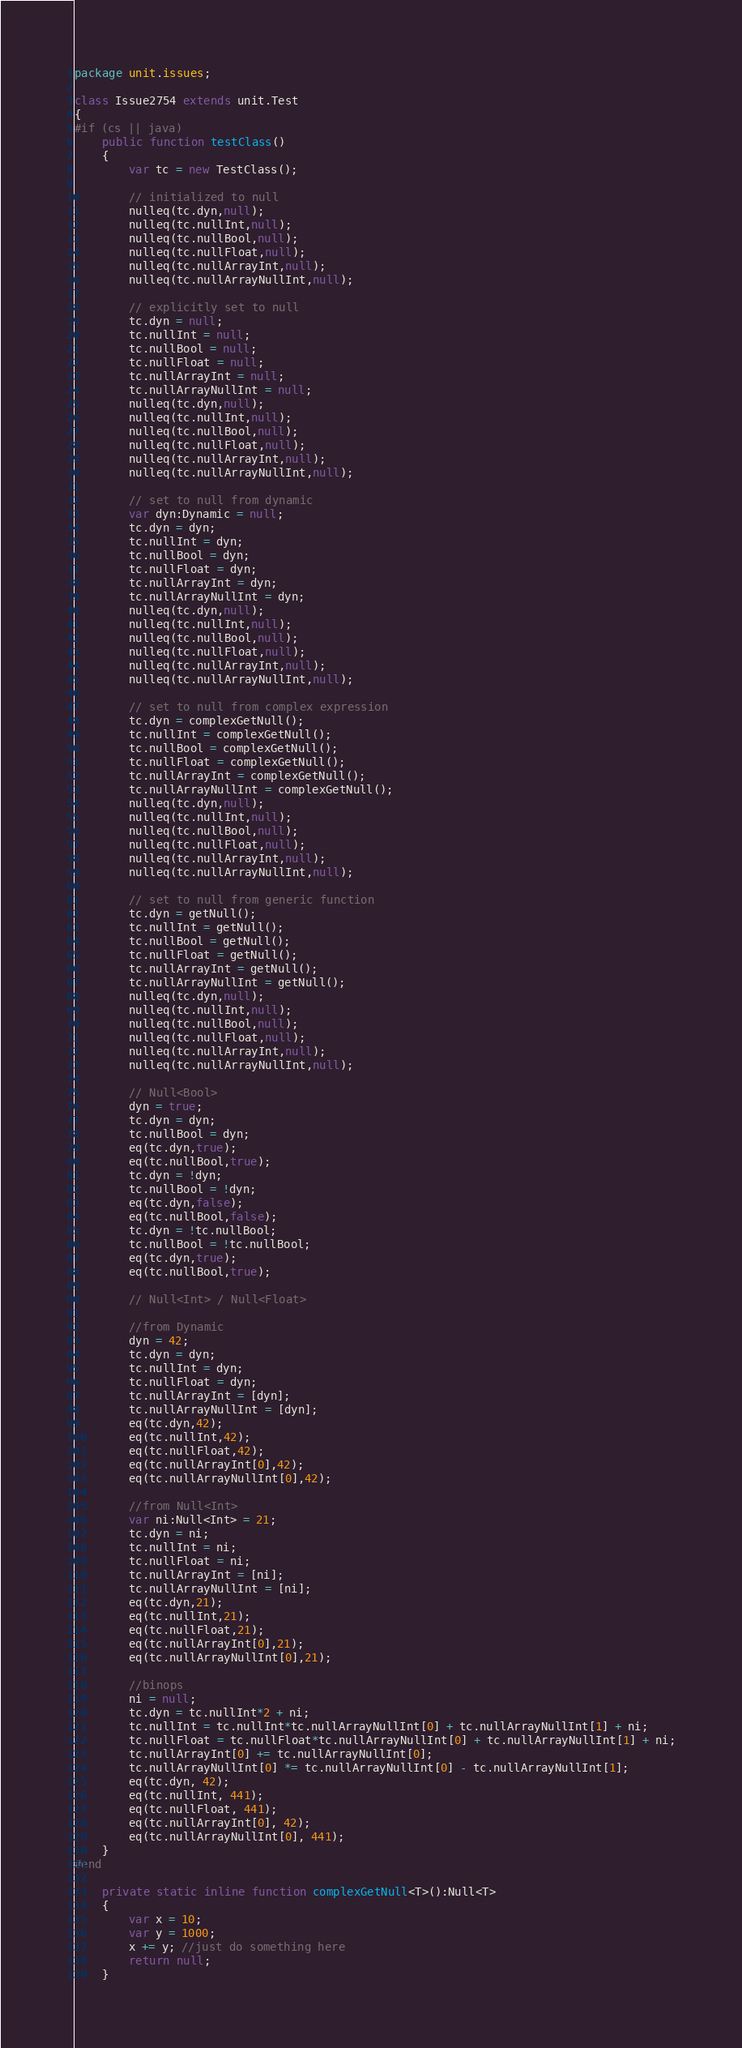<code> <loc_0><loc_0><loc_500><loc_500><_Haxe_>package unit.issues;

class Issue2754 extends unit.Test
{
#if (cs || java)
	public function testClass()
	{
		var tc = new TestClass();

		// initialized to null
		nulleq(tc.dyn,null);
		nulleq(tc.nullInt,null);
		nulleq(tc.nullBool,null);
		nulleq(tc.nullFloat,null);
		nulleq(tc.nullArrayInt,null);
		nulleq(tc.nullArrayNullInt,null);

		// explicitly set to null
		tc.dyn = null;
		tc.nullInt = null;
		tc.nullBool = null;
		tc.nullFloat = null;
		tc.nullArrayInt = null;
		tc.nullArrayNullInt = null;
		nulleq(tc.dyn,null);
		nulleq(tc.nullInt,null);
		nulleq(tc.nullBool,null);
		nulleq(tc.nullFloat,null);
		nulleq(tc.nullArrayInt,null);
		nulleq(tc.nullArrayNullInt,null);

		// set to null from dynamic
		var dyn:Dynamic = null;
		tc.dyn = dyn;
		tc.nullInt = dyn;
		tc.nullBool = dyn;
		tc.nullFloat = dyn;
		tc.nullArrayInt = dyn;
		tc.nullArrayNullInt = dyn;
		nulleq(tc.dyn,null);
		nulleq(tc.nullInt,null);
		nulleq(tc.nullBool,null);
		nulleq(tc.nullFloat,null);
		nulleq(tc.nullArrayInt,null);
		nulleq(tc.nullArrayNullInt,null);

		// set to null from complex expression
		tc.dyn = complexGetNull();
		tc.nullInt = complexGetNull();
		tc.nullBool = complexGetNull();
		tc.nullFloat = complexGetNull();
		tc.nullArrayInt = complexGetNull();
		tc.nullArrayNullInt = complexGetNull();
		nulleq(tc.dyn,null);
		nulleq(tc.nullInt,null);
		nulleq(tc.nullBool,null);
		nulleq(tc.nullFloat,null);
		nulleq(tc.nullArrayInt,null);
		nulleq(tc.nullArrayNullInt,null);

		// set to null from generic function
		tc.dyn = getNull();
		tc.nullInt = getNull();
		tc.nullBool = getNull();
		tc.nullFloat = getNull();
		tc.nullArrayInt = getNull();
		tc.nullArrayNullInt = getNull();
		nulleq(tc.dyn,null);
		nulleq(tc.nullInt,null);
		nulleq(tc.nullBool,null);
		nulleq(tc.nullFloat,null);
		nulleq(tc.nullArrayInt,null);
		nulleq(tc.nullArrayNullInt,null);

		// Null<Bool>
		dyn = true;
		tc.dyn = dyn;
		tc.nullBool = dyn;
		eq(tc.dyn,true);
		eq(tc.nullBool,true);
		tc.dyn = !dyn;
		tc.nullBool = !dyn;
		eq(tc.dyn,false);
		eq(tc.nullBool,false);
		tc.dyn = !tc.nullBool;
		tc.nullBool = !tc.nullBool;
		eq(tc.dyn,true);
		eq(tc.nullBool,true);

		// Null<Int> / Null<Float>

		//from Dynamic
		dyn = 42;
		tc.dyn = dyn;
		tc.nullInt = dyn;
		tc.nullFloat = dyn;
		tc.nullArrayInt = [dyn];
		tc.nullArrayNullInt = [dyn];
		eq(tc.dyn,42);
		eq(tc.nullInt,42);
		eq(tc.nullFloat,42);
		eq(tc.nullArrayInt[0],42);
		eq(tc.nullArrayNullInt[0],42);

		//from Null<Int>
		var ni:Null<Int> = 21;
		tc.dyn = ni;
		tc.nullInt = ni;
		tc.nullFloat = ni;
		tc.nullArrayInt = [ni];
		tc.nullArrayNullInt = [ni];
		eq(tc.dyn,21);
		eq(tc.nullInt,21);
		eq(tc.nullFloat,21);
		eq(tc.nullArrayInt[0],21);
		eq(tc.nullArrayNullInt[0],21);

		//binops
		ni = null;
		tc.dyn = tc.nullInt*2 + ni;
		tc.nullInt = tc.nullInt*tc.nullArrayNullInt[0] + tc.nullArrayNullInt[1] + ni;
		tc.nullFloat = tc.nullFloat*tc.nullArrayNullInt[0] + tc.nullArrayNullInt[1] + ni;
		tc.nullArrayInt[0] += tc.nullArrayNullInt[0];
		tc.nullArrayNullInt[0] *= tc.nullArrayNullInt[0] - tc.nullArrayNullInt[1];
		eq(tc.dyn, 42);
		eq(tc.nullInt, 441);
		eq(tc.nullFloat, 441);
		eq(tc.nullArrayInt[0], 42);
		eq(tc.nullArrayNullInt[0], 441);
	}
#end

	private static inline function complexGetNull<T>():Null<T>
	{
		var x = 10;
		var y = 1000;
		x += y; //just do something here
		return null;
	}
</code> 